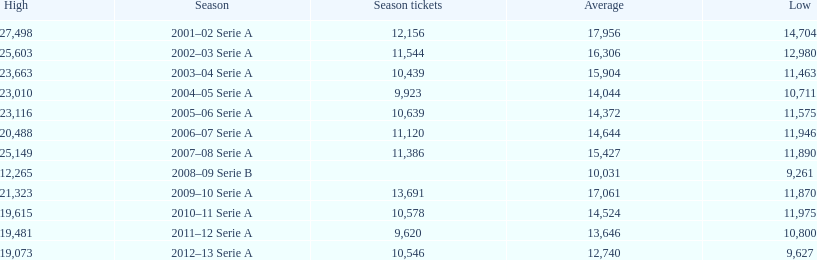How many seasons at the stadio ennio tardini had 11,000 or more season tickets? 5. 